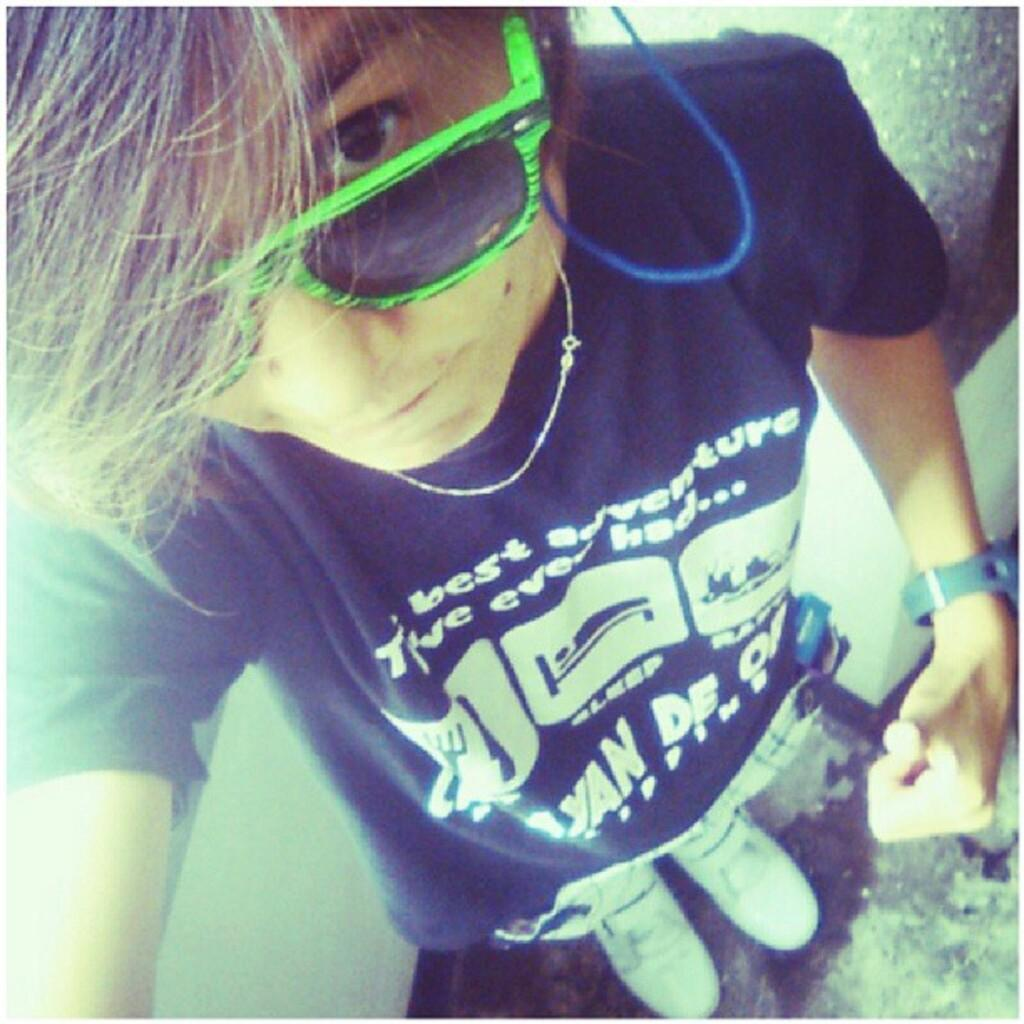Who or what is present in the image? There is a person in the image. What is the person wearing on their upper body? The person is wearing a black t-shirt. What type of protective eyewear is the person wearing? The person is wearing goggles. What accessory is visible on the person's wrist? The person is wearing a watch. What type of news can be heard in the background of the image? There is no audio or background noise present in the image, so it is not possible to determine if any news can be heard. 